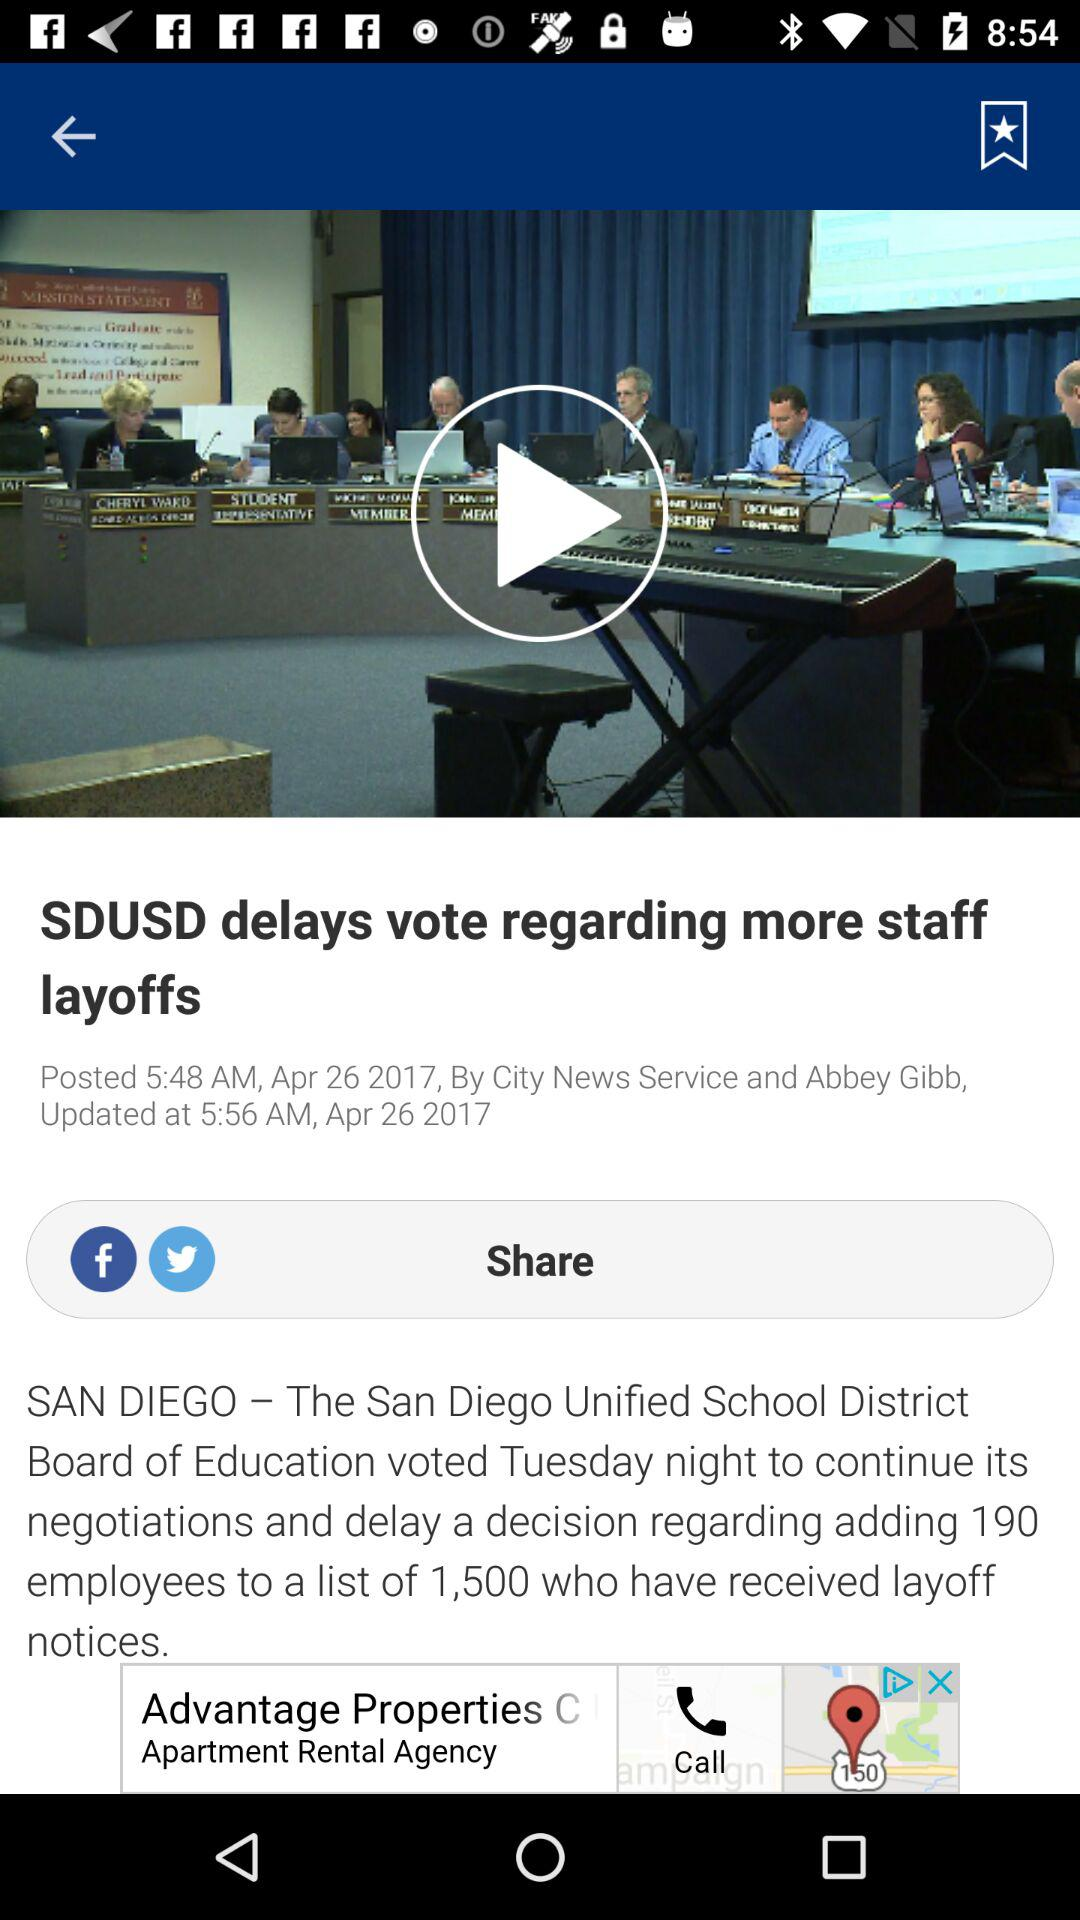How many employees have received layoff notices?
Answer the question using a single word or phrase. 1,500 